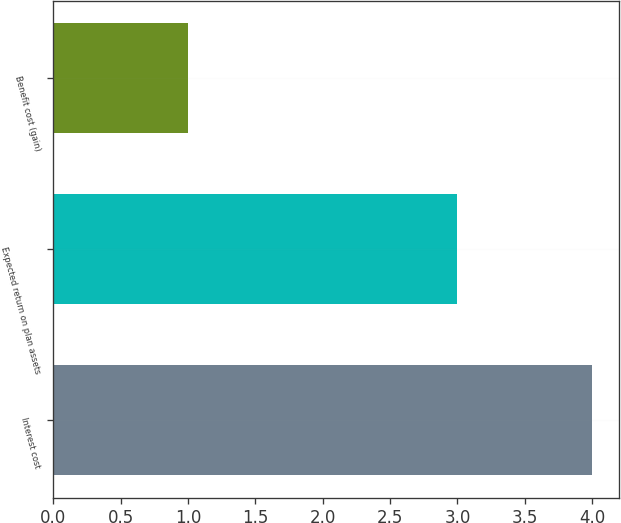<chart> <loc_0><loc_0><loc_500><loc_500><bar_chart><fcel>Interest cost<fcel>Expected return on plan assets<fcel>Benefit cost (gain)<nl><fcel>4<fcel>3<fcel>1<nl></chart> 